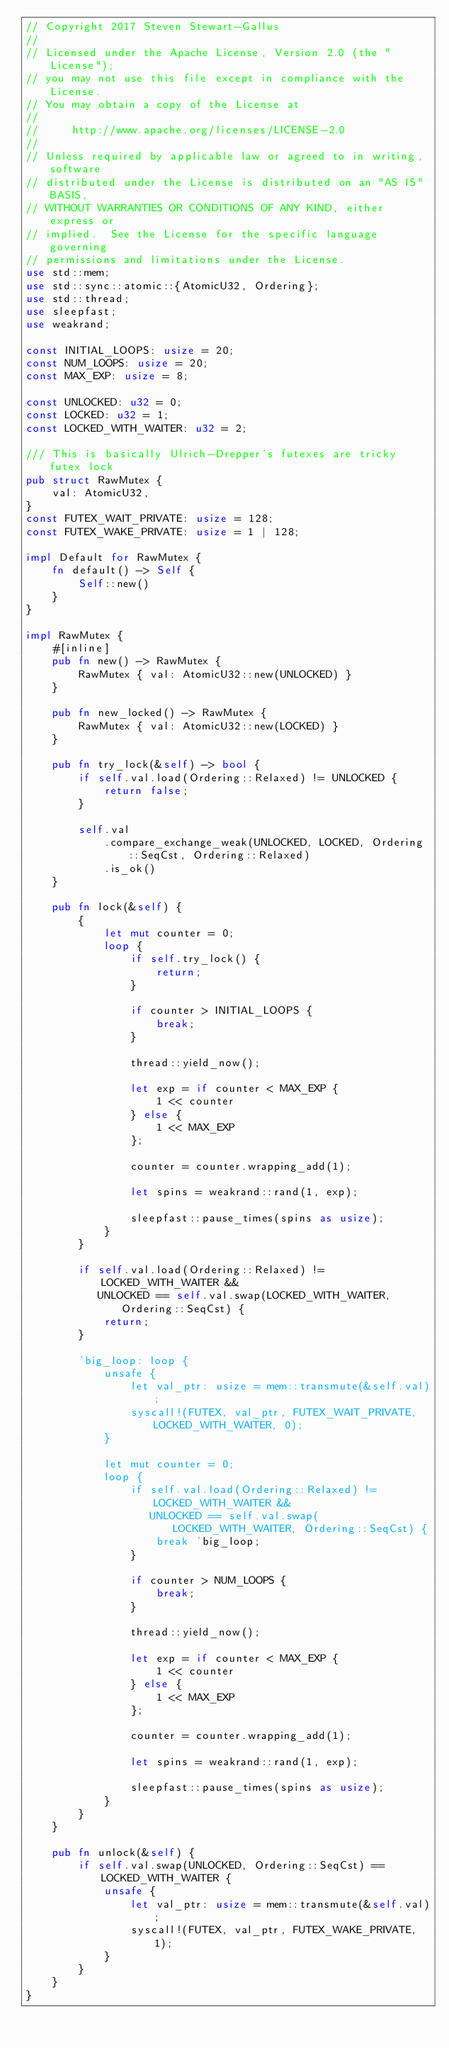<code> <loc_0><loc_0><loc_500><loc_500><_Rust_>// Copyright 2017 Steven Stewart-Gallus
//
// Licensed under the Apache License, Version 2.0 (the "License");
// you may not use this file except in compliance with the License.
// You may obtain a copy of the License at
//
//     http://www.apache.org/licenses/LICENSE-2.0
//
// Unless required by applicable law or agreed to in writing, software
// distributed under the License is distributed on an "AS IS" BASIS,
// WITHOUT WARRANTIES OR CONDITIONS OF ANY KIND, either express or
// implied.  See the License for the specific language governing
// permissions and limitations under the License.
use std::mem;
use std::sync::atomic::{AtomicU32, Ordering};
use std::thread;
use sleepfast;
use weakrand;

const INITIAL_LOOPS: usize = 20;
const NUM_LOOPS: usize = 20;
const MAX_EXP: usize = 8;

const UNLOCKED: u32 = 0;
const LOCKED: u32 = 1;
const LOCKED_WITH_WAITER: u32 = 2;

/// This is basically Ulrich-Drepper's futexes are tricky futex lock
pub struct RawMutex {
    val: AtomicU32,
}
const FUTEX_WAIT_PRIVATE: usize = 128;
const FUTEX_WAKE_PRIVATE: usize = 1 | 128;

impl Default for RawMutex {
    fn default() -> Self {
        Self::new()
    }
}

impl RawMutex {
    #[inline]
    pub fn new() -> RawMutex {
        RawMutex { val: AtomicU32::new(UNLOCKED) }
    }

    pub fn new_locked() -> RawMutex {
        RawMutex { val: AtomicU32::new(LOCKED) }
    }

    pub fn try_lock(&self) -> bool {
        if self.val.load(Ordering::Relaxed) != UNLOCKED {
            return false;
        }

        self.val
            .compare_exchange_weak(UNLOCKED, LOCKED, Ordering::SeqCst, Ordering::Relaxed)
            .is_ok()
    }

    pub fn lock(&self) {
        {
            let mut counter = 0;
            loop {
                if self.try_lock() {
                    return;
                }

                if counter > INITIAL_LOOPS {
                    break;
                }

                thread::yield_now();

                let exp = if counter < MAX_EXP {
                    1 << counter
                } else {
                    1 << MAX_EXP
                };

                counter = counter.wrapping_add(1);

                let spins = weakrand::rand(1, exp);

                sleepfast::pause_times(spins as usize);
            }
        }

        if self.val.load(Ordering::Relaxed) != LOCKED_WITH_WAITER &&
           UNLOCKED == self.val.swap(LOCKED_WITH_WAITER, Ordering::SeqCst) {
            return;
        }

        'big_loop: loop {
            unsafe {
                let val_ptr: usize = mem::transmute(&self.val);
                syscall!(FUTEX, val_ptr, FUTEX_WAIT_PRIVATE, LOCKED_WITH_WAITER, 0);
            }

            let mut counter = 0;
            loop {
                if self.val.load(Ordering::Relaxed) != LOCKED_WITH_WAITER &&
                   UNLOCKED == self.val.swap(LOCKED_WITH_WAITER, Ordering::SeqCst) {
                    break 'big_loop;
                }

                if counter > NUM_LOOPS {
                    break;
                }

                thread::yield_now();

                let exp = if counter < MAX_EXP {
                    1 << counter
                } else {
                    1 << MAX_EXP
                };

                counter = counter.wrapping_add(1);

                let spins = weakrand::rand(1, exp);

                sleepfast::pause_times(spins as usize);
            }
        }
    }

    pub fn unlock(&self) {
        if self.val.swap(UNLOCKED, Ordering::SeqCst) == LOCKED_WITH_WAITER {
            unsafe {
                let val_ptr: usize = mem::transmute(&self.val);
                syscall!(FUTEX, val_ptr, FUTEX_WAKE_PRIVATE, 1);
            }
        }
    }
}
</code> 